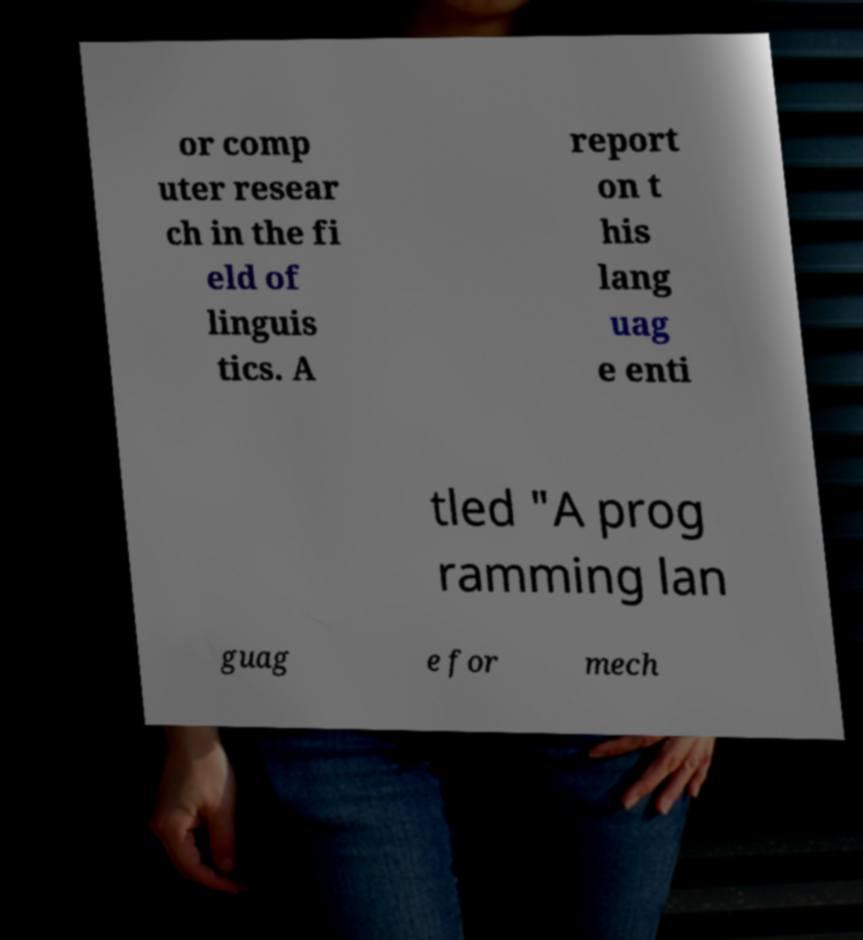For documentation purposes, I need the text within this image transcribed. Could you provide that? or comp uter resear ch in the fi eld of linguis tics. A report on t his lang uag e enti tled "A prog ramming lan guag e for mech 